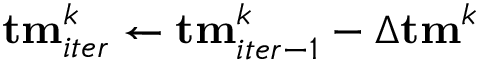Convert formula to latex. <formula><loc_0><loc_0><loc_500><loc_500>{ t m } _ { i t e r } ^ { k } \gets { t m } _ { i t e r - 1 } ^ { k } - \Delta { t m } ^ { k }</formula> 